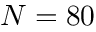Convert formula to latex. <formula><loc_0><loc_0><loc_500><loc_500>N = 8 0</formula> 